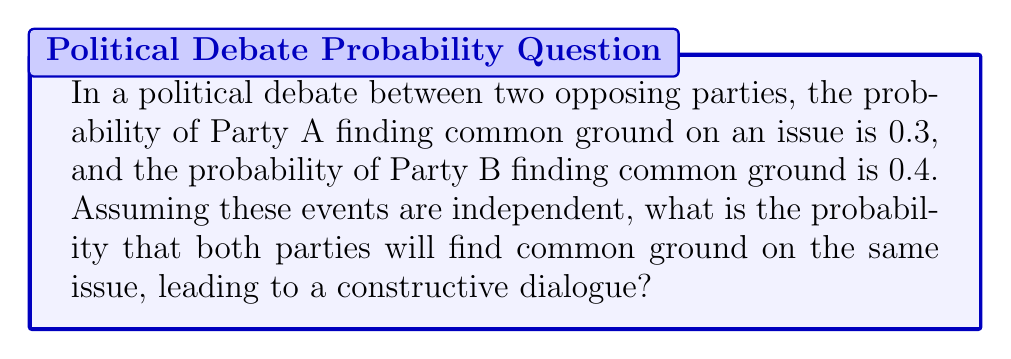Can you answer this question? Let's approach this step-by-step:

1) Let $A$ be the event that Party A finds common ground, and $B$ be the event that Party B finds common ground.

2) We're given:
   $P(A) = 0.3$
   $P(B) = 0.4$

3) We need to find the probability of both events occurring simultaneously, which is denoted as $P(A \cap B)$.

4) Since the events are independent, we can use the multiplication rule of probability:

   $P(A \cap B) = P(A) \times P(B)$

5) Substituting the values:

   $P(A \cap B) = 0.3 \times 0.4$

6) Calculating:

   $P(A \cap B) = 0.12$

Therefore, the probability that both parties will find common ground on the same issue is 0.12 or 12%.
Answer: $0.12$ 